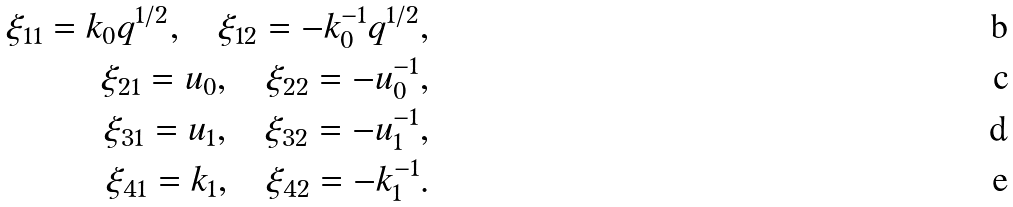Convert formula to latex. <formula><loc_0><loc_0><loc_500><loc_500>\xi _ { 1 1 } = k _ { 0 } q ^ { 1 / 2 } , \quad \xi _ { 1 2 } = - k _ { 0 } ^ { - 1 } q ^ { 1 / 2 } , \\ \xi _ { 2 1 } = u _ { 0 } , \quad \xi _ { 2 2 } = - u _ { 0 } ^ { - 1 } , \\ \xi _ { 3 1 } = u _ { 1 } , \quad \xi _ { 3 2 } = - u _ { 1 } ^ { - 1 } , \\ \xi _ { 4 1 } = k _ { 1 } , \quad \xi _ { 4 2 } = - k _ { 1 } ^ { - 1 } .</formula> 